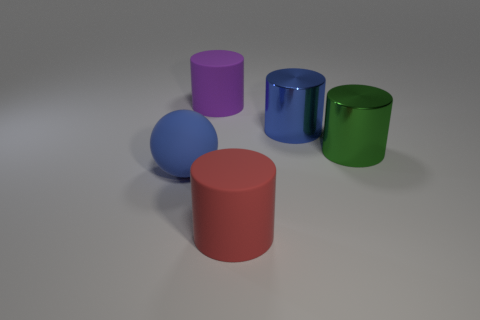What shape is the big rubber thing to the right of the big rubber cylinder to the left of the large rubber object that is on the right side of the large purple matte cylinder?
Give a very brief answer. Cylinder. Is the number of large red matte cylinders in front of the purple rubber thing less than the number of objects that are behind the large sphere?
Your answer should be compact. Yes. Is there another large shiny ball of the same color as the big sphere?
Provide a short and direct response. No. Are the large green cylinder and the big thing in front of the large blue matte sphere made of the same material?
Provide a short and direct response. No. Are there any objects that are on the left side of the large green metallic cylinder to the right of the red object?
Offer a very short reply. Yes. There is a large cylinder that is in front of the large blue shiny cylinder and on the left side of the green metal cylinder; what color is it?
Give a very brief answer. Red. How many other rubber cylinders have the same size as the red cylinder?
Provide a succinct answer. 1. Is the material of the big cylinder that is to the left of the red cylinder the same as the large blue thing that is behind the large green metallic thing?
Your answer should be very brief. No. What is the material of the cylinder that is behind the metallic object that is on the left side of the big green metal object?
Offer a very short reply. Rubber. There is a blue thing that is to the left of the purple cylinder; what is its material?
Offer a very short reply. Rubber. 